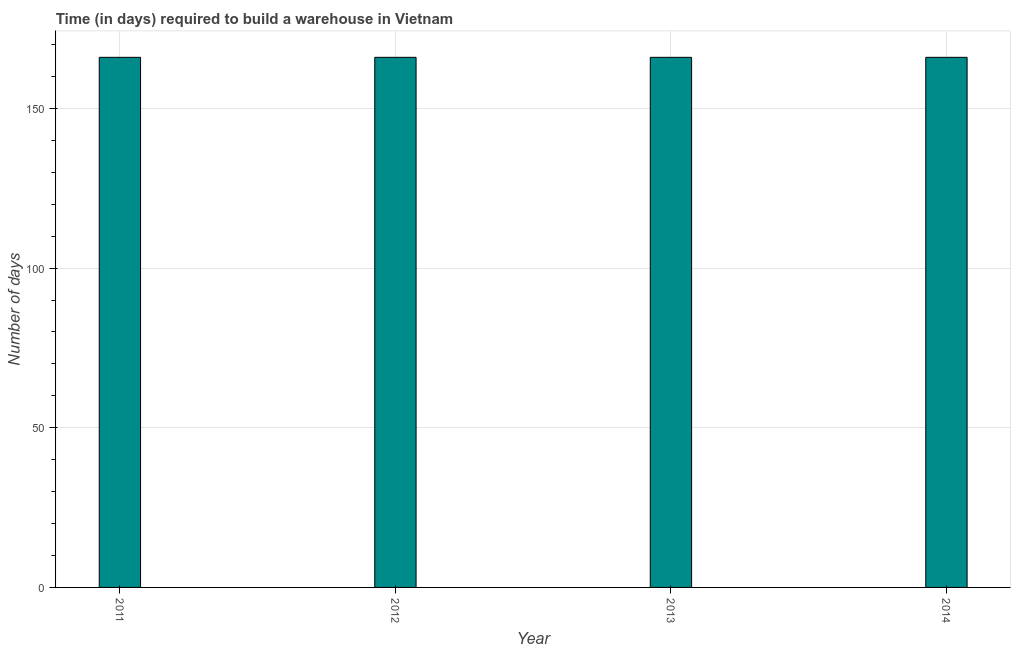What is the title of the graph?
Your answer should be very brief. Time (in days) required to build a warehouse in Vietnam. What is the label or title of the Y-axis?
Make the answer very short. Number of days. What is the time required to build a warehouse in 2011?
Offer a terse response. 166. Across all years, what is the maximum time required to build a warehouse?
Give a very brief answer. 166. Across all years, what is the minimum time required to build a warehouse?
Make the answer very short. 166. In which year was the time required to build a warehouse maximum?
Make the answer very short. 2011. What is the sum of the time required to build a warehouse?
Your response must be concise. 664. What is the average time required to build a warehouse per year?
Offer a very short reply. 166. What is the median time required to build a warehouse?
Give a very brief answer. 166. What is the ratio of the time required to build a warehouse in 2011 to that in 2014?
Keep it short and to the point. 1. Is the difference between the time required to build a warehouse in 2011 and 2013 greater than the difference between any two years?
Make the answer very short. Yes. Are all the bars in the graph horizontal?
Give a very brief answer. No. How many years are there in the graph?
Make the answer very short. 4. What is the difference between two consecutive major ticks on the Y-axis?
Provide a short and direct response. 50. What is the Number of days in 2011?
Your response must be concise. 166. What is the Number of days in 2012?
Your answer should be very brief. 166. What is the Number of days of 2013?
Offer a very short reply. 166. What is the Number of days of 2014?
Give a very brief answer. 166. What is the difference between the Number of days in 2011 and 2012?
Keep it short and to the point. 0. What is the difference between the Number of days in 2012 and 2013?
Provide a short and direct response. 0. What is the ratio of the Number of days in 2011 to that in 2012?
Your answer should be compact. 1. What is the ratio of the Number of days in 2011 to that in 2014?
Provide a succinct answer. 1. What is the ratio of the Number of days in 2012 to that in 2013?
Your answer should be very brief. 1. 